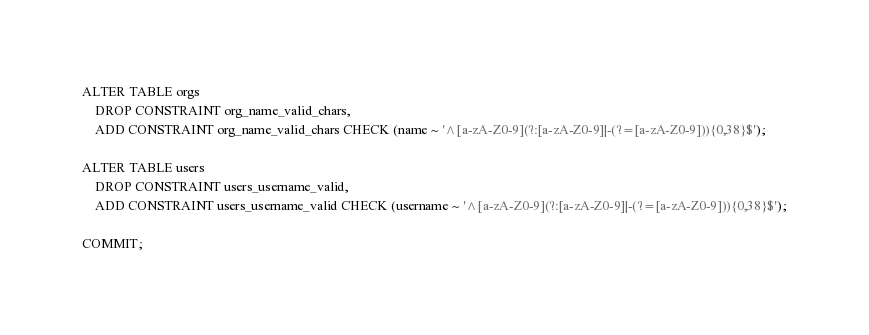<code> <loc_0><loc_0><loc_500><loc_500><_SQL_>
ALTER TABLE orgs
	DROP CONSTRAINT org_name_valid_chars,
	ADD CONSTRAINT org_name_valid_chars CHECK (name ~ '^[a-zA-Z0-9](?:[a-zA-Z0-9]|-(?=[a-zA-Z0-9])){0,38}$');

ALTER TABLE users
	DROP CONSTRAINT users_username_valid,
	ADD CONSTRAINT users_username_valid CHECK (username ~ '^[a-zA-Z0-9](?:[a-zA-Z0-9]|-(?=[a-zA-Z0-9])){0,38}$');

COMMIT;</code> 